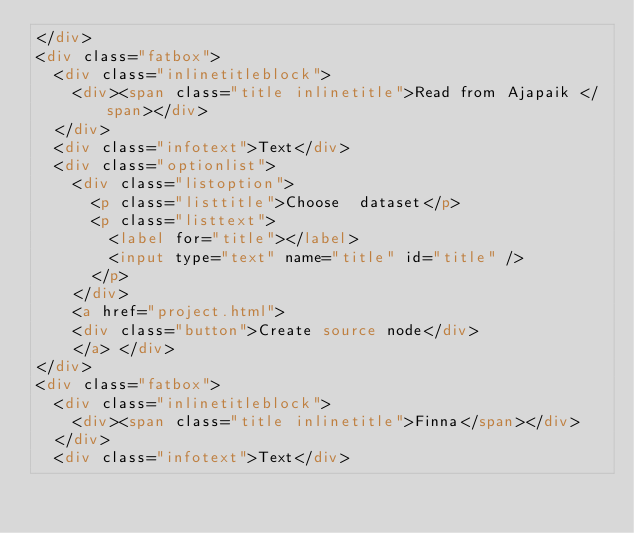Convert code to text. <code><loc_0><loc_0><loc_500><loc_500><_HTML_></div>
<div class="fatbox">
  <div class="inlinetitleblock">
    <div><span class="title inlinetitle">Read from Ajapaik </span></div>
  </div>
  <div class="infotext">Text</div>
  <div class="optionlist">
    <div class="listoption">
      <p class="listtitle">Choose  dataset</p>
      <p class="listtext">
        <label for="title"></label>
        <input type="text" name="title" id="title" />
      </p>
    </div>
    <a href="project.html">
    <div class="button">Create source node</div>
    </a> </div>
</div>
<div class="fatbox">
  <div class="inlinetitleblock">
    <div><span class="title inlinetitle">Finna</span></div>
  </div>
  <div class="infotext">Text</div></code> 